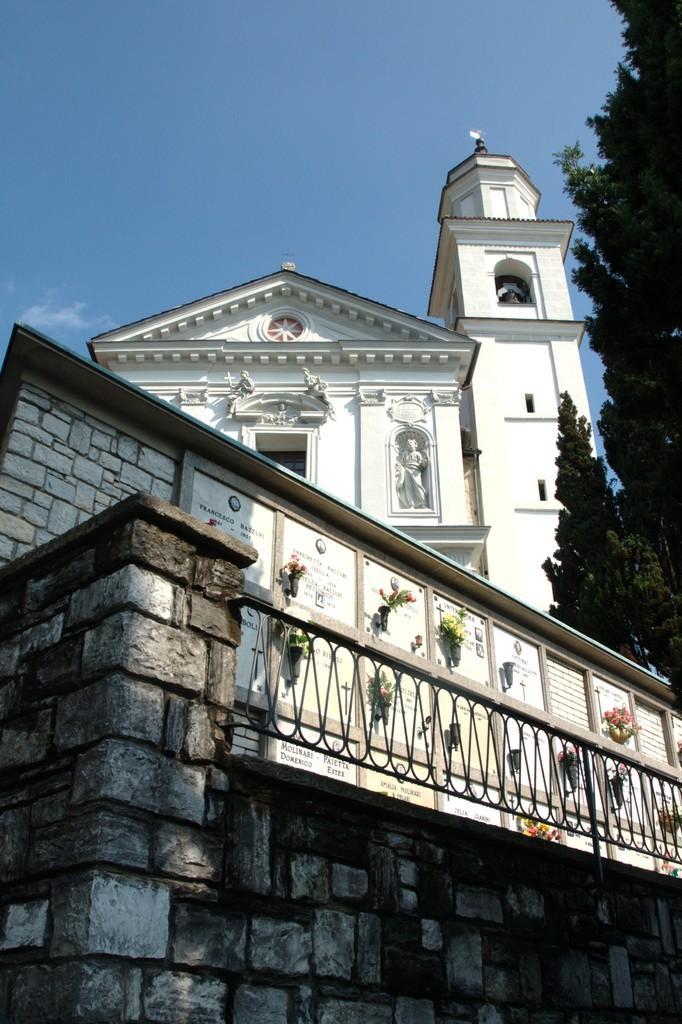Describe this image in one or two sentences. In this image there is a building in the middle. On the right side there are trees. At the bottom there is a wall on which there is fence. At the top there is the sky. 